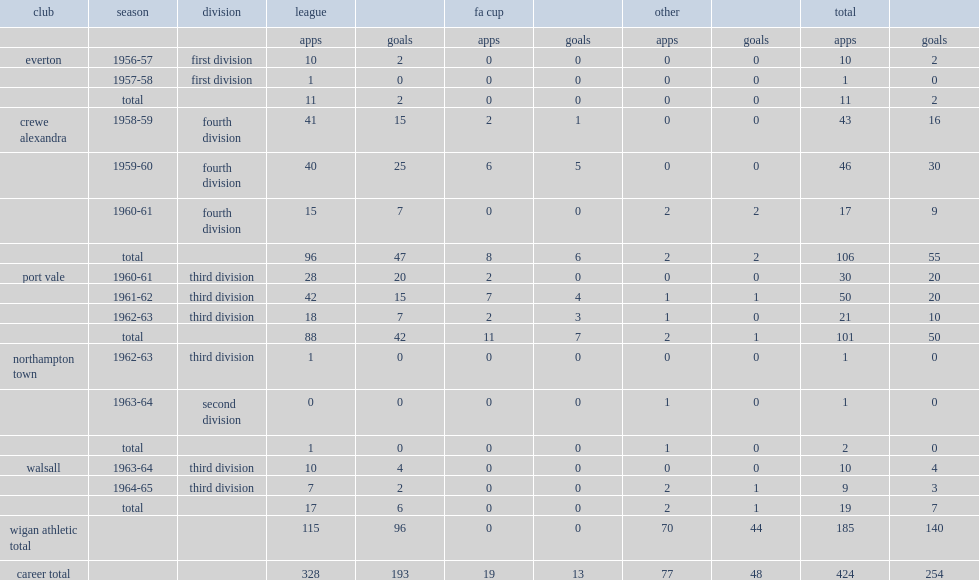How many goals did bert llewellyn score across all competitions at wigan? 140.0. 